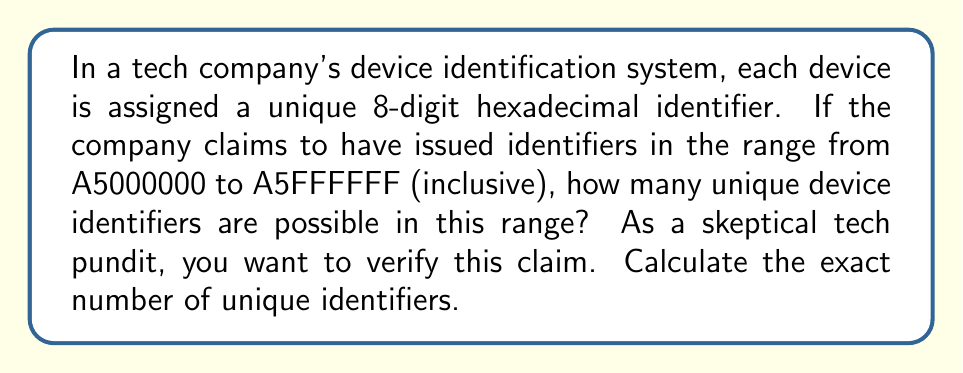Give your solution to this math problem. Let's approach this step-by-step:

1) First, we need to understand the hexadecimal system. It uses 16 digits: 0-9 and A-F.

2) The range starts at A5000000 and ends at A5FFFFFF. The first two digits (A5) are fixed for all identifiers in this range.

3) We need to count how many numbers are between 000000 and FFFFFF in hexadecimal.

4) In decimal, this would be equivalent to counting from 0 to 16^6 - 1, because:
   
   $$(16^6 - 1)_{10} = \text{FFFFFF}_{16}$$

5) Therefore, the number of unique identifiers is:

   $$16^6 = 16,777,216$$

6) We can verify this by subtracting the start of the range from the end and adding 1 (to include both endpoints):

   $$(\text{A5FFFFFF}_{16} - \text{A5000000}_{16}) + 1 = (\text{FFFFFF}_{16} - \text{000000}_{16}) + 1 = 16^6$$

This calculation confirms the initial result.
Answer: 16,777,216 